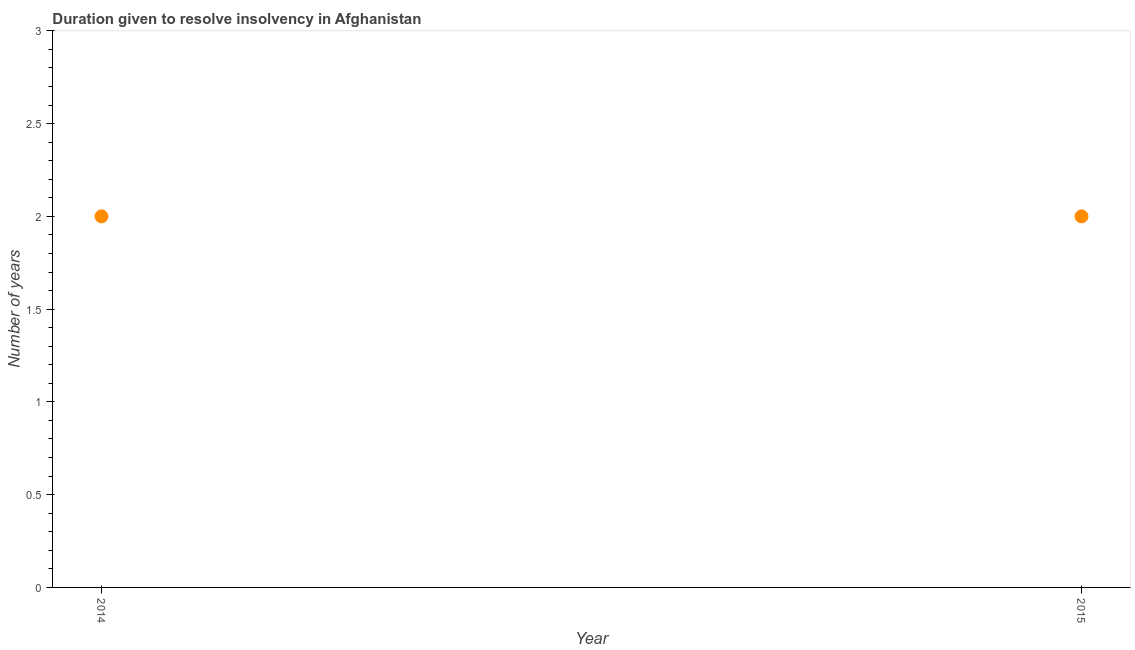What is the number of years to resolve insolvency in 2014?
Give a very brief answer. 2. Across all years, what is the maximum number of years to resolve insolvency?
Your answer should be very brief. 2. Across all years, what is the minimum number of years to resolve insolvency?
Offer a very short reply. 2. What is the sum of the number of years to resolve insolvency?
Keep it short and to the point. 4. What is the average number of years to resolve insolvency per year?
Keep it short and to the point. 2. What is the median number of years to resolve insolvency?
Ensure brevity in your answer.  2. In how many years, is the number of years to resolve insolvency greater than 0.30000000000000004 ?
Ensure brevity in your answer.  2. Do a majority of the years between 2015 and 2014 (inclusive) have number of years to resolve insolvency greater than 0.6 ?
Provide a short and direct response. No. What is the ratio of the number of years to resolve insolvency in 2014 to that in 2015?
Your answer should be very brief. 1. In how many years, is the number of years to resolve insolvency greater than the average number of years to resolve insolvency taken over all years?
Give a very brief answer. 0. How many dotlines are there?
Your answer should be compact. 1. What is the difference between two consecutive major ticks on the Y-axis?
Give a very brief answer. 0.5. Are the values on the major ticks of Y-axis written in scientific E-notation?
Provide a succinct answer. No. Does the graph contain any zero values?
Provide a short and direct response. No. What is the title of the graph?
Make the answer very short. Duration given to resolve insolvency in Afghanistan. What is the label or title of the X-axis?
Offer a terse response. Year. What is the label or title of the Y-axis?
Keep it short and to the point. Number of years. What is the Number of years in 2014?
Provide a short and direct response. 2. What is the Number of years in 2015?
Your answer should be compact. 2. What is the difference between the Number of years in 2014 and 2015?
Your response must be concise. 0. 